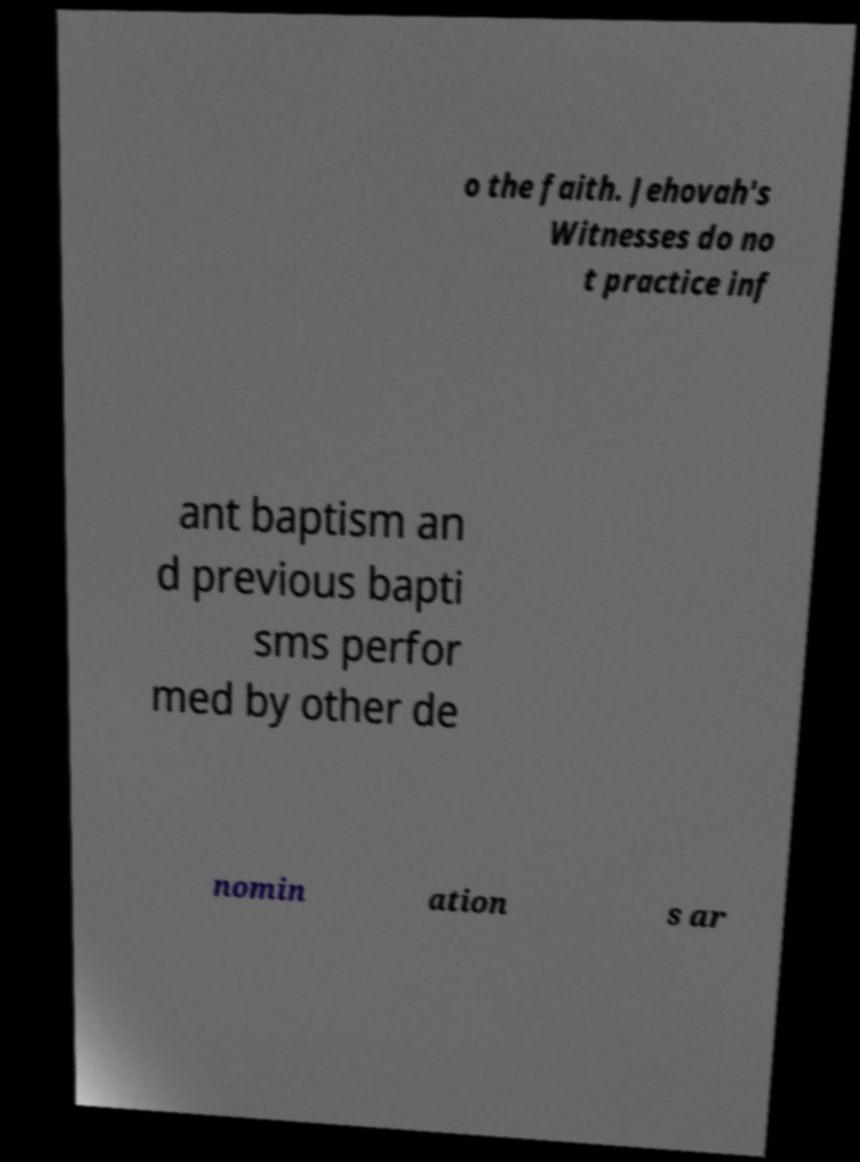What messages or text are displayed in this image? I need them in a readable, typed format. o the faith. Jehovah's Witnesses do no t practice inf ant baptism an d previous bapti sms perfor med by other de nomin ation s ar 